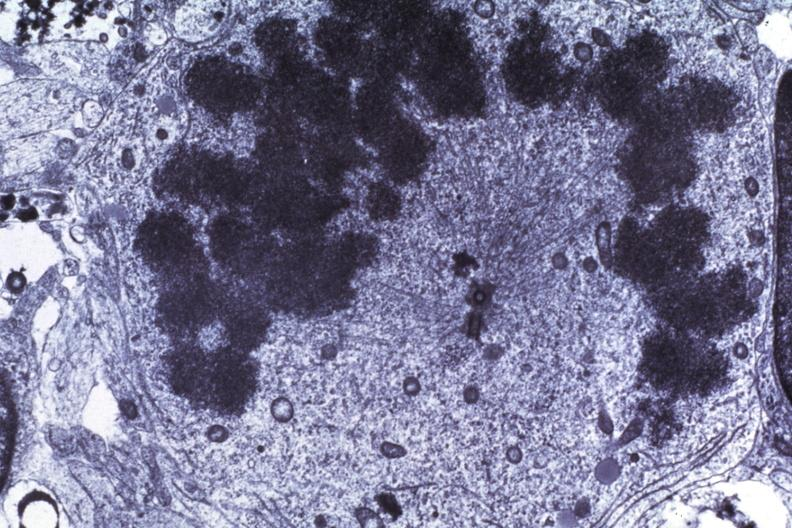does malignant adenoma show dr garcia tumors 65?
Answer the question using a single word or phrase. No 